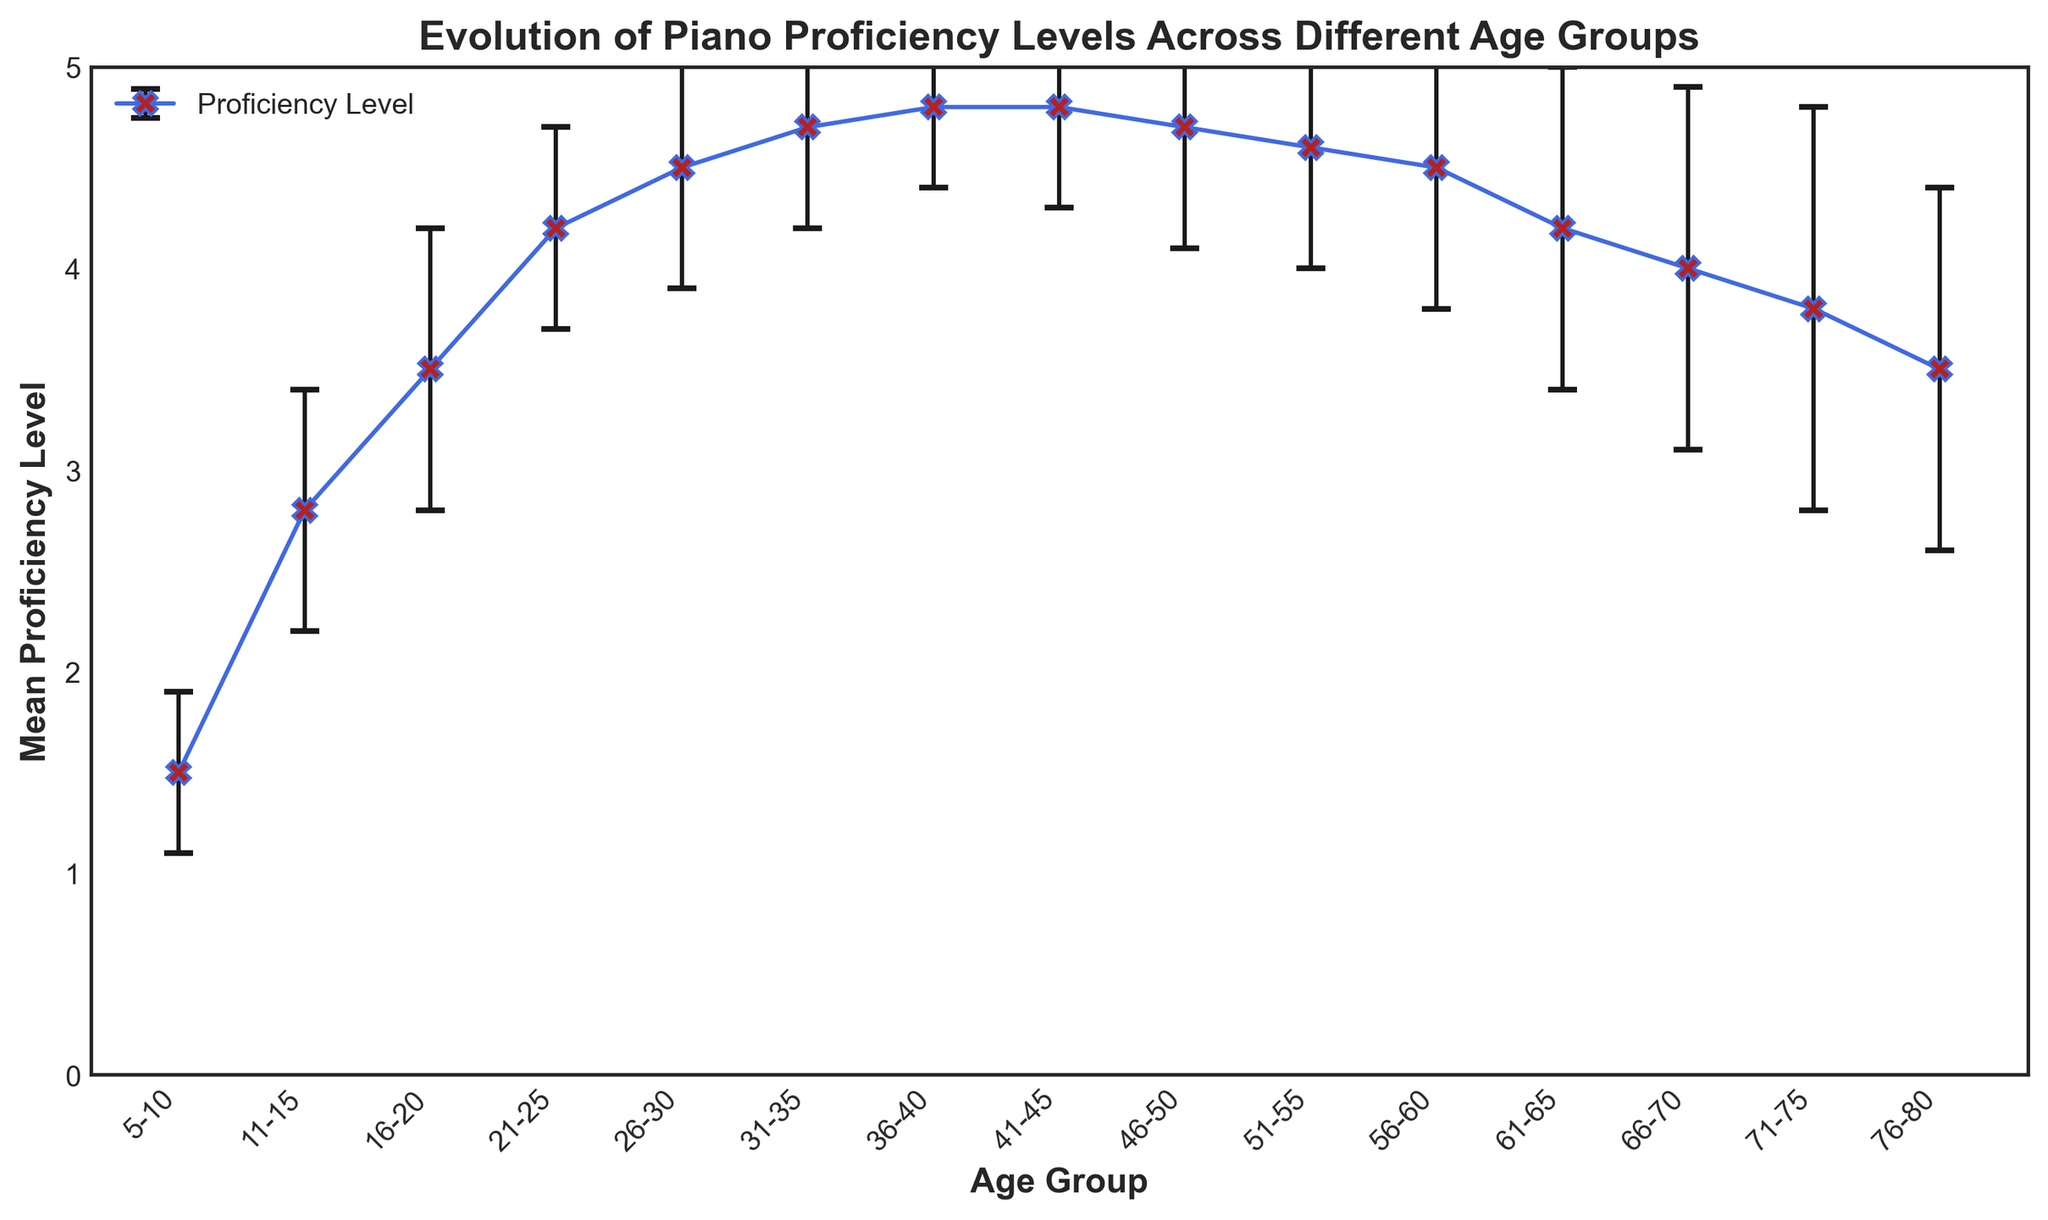Which age group has the highest mean proficiency level? The figure shows the mean proficiency levels for each age group. Identify the age group with the highest mean proficiency value by looking at the data points.
Answer: 36-40 and 41-45 How does the proficiency level change after the 21-25 age group compared to before? Examine the mean proficiency levels before and after the 21-25 age group to see if the levels increase, decrease, or remain stable. The mean proficiency generally increases before 21-25 and shows a slight decline after 21-25.
Answer: Increases before, slightly decreases after What is the range of proficiency levels for the 11-15 age group? The range can be calculated by adding and subtracting the standard deviation from the mean proficiency level for the 11-15 age group. Mean is 2.8 and standard deviation is 0.6, so the range is 2.8 ± 0.6, which is 2.2 to 3.4.
Answer: 2.2 to 3.4 Which age group has the largest standard deviation in proficiency level? Look at the error bars representing the standard deviations. The largest error bar will indicate the highest standard deviation.
Answer: 66-70 Are any age groups tied in their mean proficiency level? Check for age groups with the same mean proficiency value by observing the data points. The 36-40 and 41-45 age groups both have the same mean proficiency level of 4.8.
Answer: 36-40 and 41-45 Which age group shows the most variability in proficiency level? The most variability is indicated by the largest standard deviation. Identify the age group with the longest error bar.
Answer: 66-70 Between which two consecutive age groups does the biggest increase in mean proficiency occur? Compare the difference in mean proficiency between each pair of consecutive age groups and determine the pair with the largest increase. From 5-10 to 11-15, the mean proficiency increases by 2.8 - 1.5 = 1.3, which is the largest increase.
Answer: 5-10 to 11-15 What is the mean proficiency level for the age group with the smallest standard deviation? Identify the age group with the smallest standard deviation by looking at the shortest error bar, which is 5-10 (0.4). The mean proficiency for this group is 1.5.
Answer: 1.5 How does the proficiency level for the 61-65 age group compare to the 51-55 age group in terms of mean and standard deviation? Compare the mean and standard deviation values for both age groups. The mean for 51-55 is 4.6 with a standard deviation of 0.6, whereas 61-65 has a mean of 4.2 and a standard deviation of 0.8.
Answer: Lower mean, higher variability for 61-65 